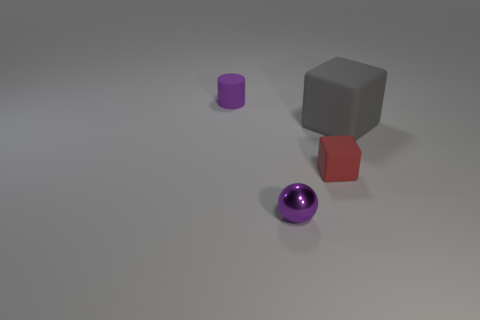Add 2 objects. How many objects exist? 6 Add 1 small cyan metal cylinders. How many small cyan metal cylinders exist? 1 Subtract 0 blue cylinders. How many objects are left? 4 Subtract all gray metal cylinders. Subtract all gray matte objects. How many objects are left? 3 Add 1 large gray matte things. How many large gray matte things are left? 2 